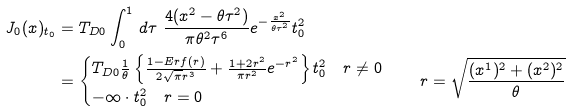Convert formula to latex. <formula><loc_0><loc_0><loc_500><loc_500>J _ { 0 } ( x ) _ { t _ { 0 } } & = T _ { D 0 } \int _ { 0 } ^ { 1 } \, d \tau \ \frac { 4 ( x ^ { 2 } - \theta \tau ^ { 2 } ) } { \pi \theta ^ { 2 } \tau ^ { 6 } } e ^ { - \frac { x ^ { 2 } } { \theta \tau ^ { 2 } } } t _ { 0 } ^ { 2 } \\ & = \begin{cases} T _ { D 0 } \frac { 1 } { \theta } \left \{ \frac { 1 - E r f ( r ) } { 2 \sqrt { \pi } r ^ { 3 } } + \frac { 1 + 2 r ^ { 2 } } { \pi r ^ { 2 } } e ^ { - r ^ { 2 } } \right \} t _ { 0 } ^ { 2 } \quad r \ne 0 \\ - \infty \cdot t _ { 0 } ^ { 2 } \quad r = 0 \end{cases} \quad r = \sqrt { \frac { ( x ^ { 1 } ) ^ { 2 } + ( x ^ { 2 } ) ^ { 2 } } { \theta } }</formula> 